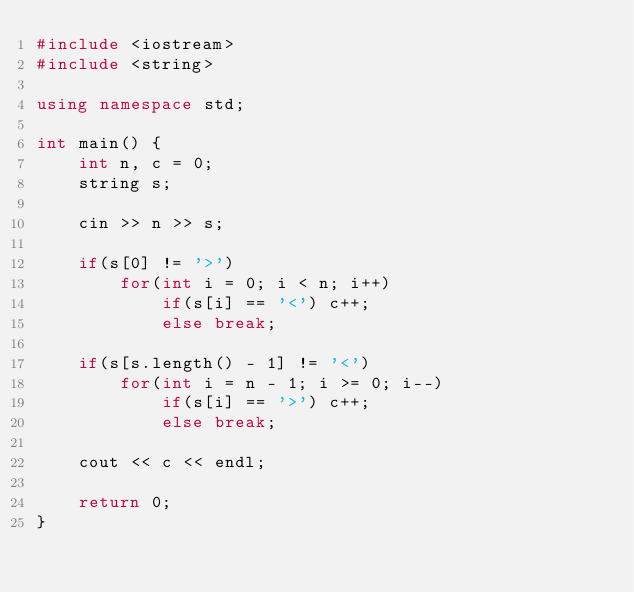Convert code to text. <code><loc_0><loc_0><loc_500><loc_500><_C++_>#include <iostream>
#include <string>

using namespace std;

int main() {
	int n, c = 0;
	string s;

	cin >> n >> s;

	if(s[0] != '>')
		for(int i = 0; i < n; i++)
			if(s[i] == '<') c++;
			else break;

	if(s[s.length() - 1] != '<')
		for(int i = n - 1; i >= 0; i--)
			if(s[i] == '>') c++;
			else break;

	cout << c << endl;

	return 0;
}
</code> 